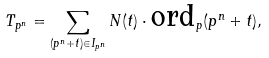Convert formula to latex. <formula><loc_0><loc_0><loc_500><loc_500>T _ { p ^ { n } } = \sum _ { ( p ^ { n } + t ) \in I _ { p ^ { n } } } N ( t ) \cdot \text {ord} _ { p } ( p ^ { n } + t ) ,</formula> 